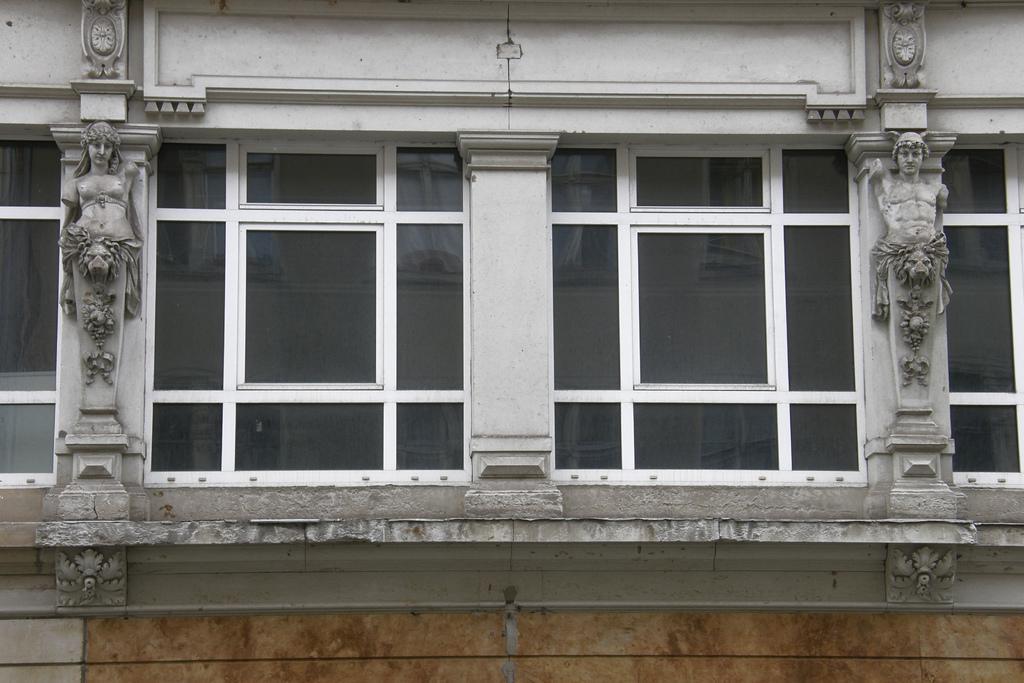In one or two sentences, can you explain what this image depicts? In this image there is one building and sculptures, and in the center there are glass windows. 